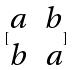<formula> <loc_0><loc_0><loc_500><loc_500>[ \begin{matrix} a & b \\ b & a \end{matrix} ]</formula> 